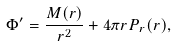<formula> <loc_0><loc_0><loc_500><loc_500>\Phi ^ { \prime } = \frac { M ( r ) } { r ^ { 2 } } + 4 \pi r P _ { r } ( r ) ,</formula> 